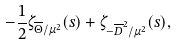<formula> <loc_0><loc_0><loc_500><loc_500>- \frac { 1 } { 2 } \zeta _ { \overline { \Theta } / \mu ^ { 2 } } ( s ) + \zeta _ { - \overline { D } ^ { 2 } / \mu ^ { 2 } } ( s ) ,</formula> 